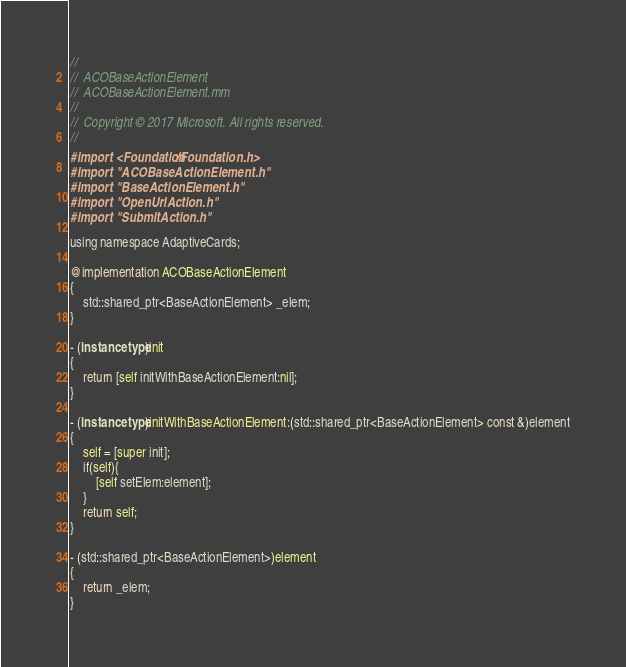Convert code to text. <code><loc_0><loc_0><loc_500><loc_500><_ObjectiveC_>//
//  ACOBaseActionElement
//  ACOBaseActionElement.mm
//
//  Copyright © 2017 Microsoft. All rights reserved.
//
#import <Foundation/Foundation.h>
#import "ACOBaseActionElement.h"
#import "BaseActionElement.h"
#import "OpenUrlAction.h"
#import "SubmitAction.h"

using namespace AdaptiveCards;

@implementation ACOBaseActionElement
{
    std::shared_ptr<BaseActionElement> _elem;
}

- (instancetype)init
{
    return [self initWithBaseActionElement:nil];
}

- (instancetype)initWithBaseActionElement:(std::shared_ptr<BaseActionElement> const &)element
{
    self = [super init];
    if(self){
        [self setElem:element];
    }
    return self;
}

- (std::shared_ptr<BaseActionElement>)element
{
    return _elem;
}
</code> 